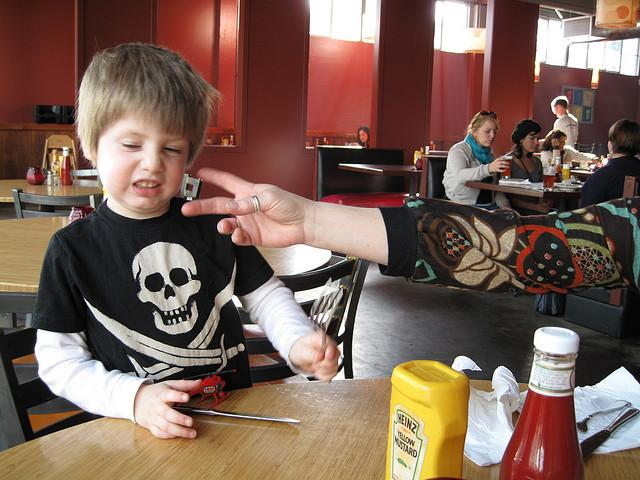Where is the table the boy is sitting at?

Choices:
A) police station
B) library
C) post office
D) restaurant restaurant 